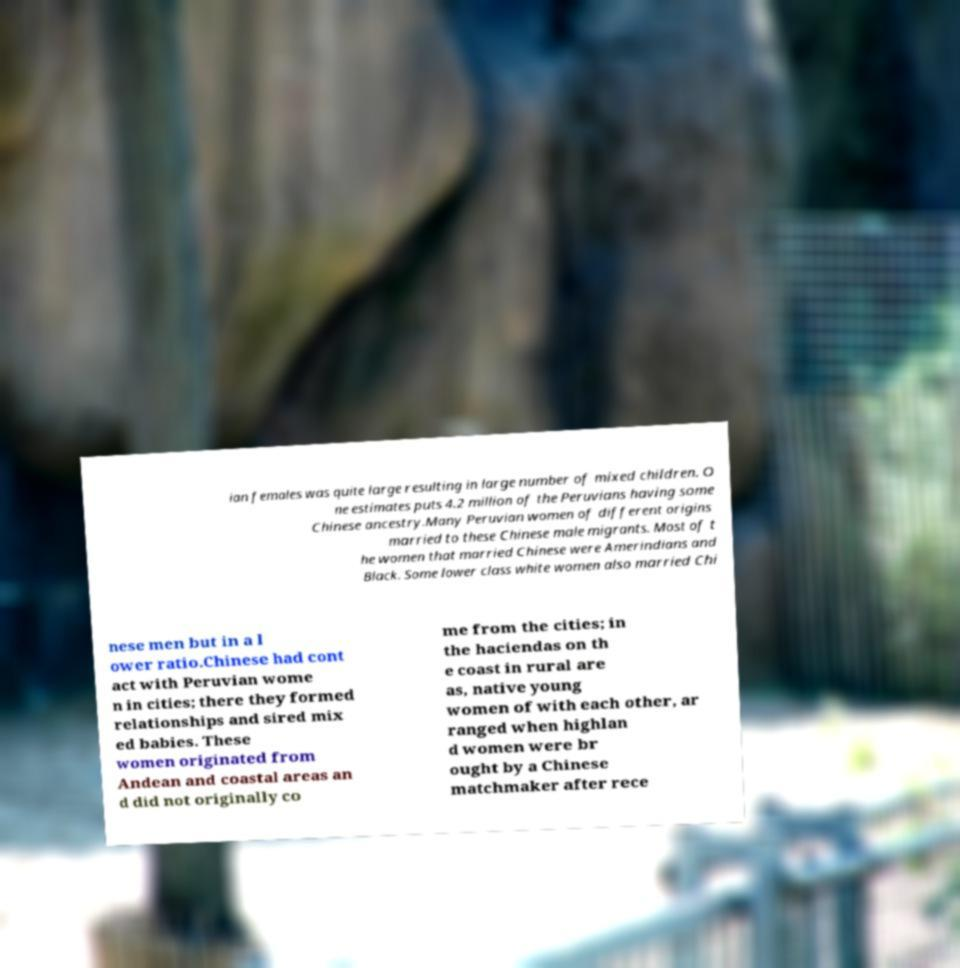I need the written content from this picture converted into text. Can you do that? ian females was quite large resulting in large number of mixed children. O ne estimates puts 4.2 million of the Peruvians having some Chinese ancestry.Many Peruvian women of different origins married to these Chinese male migrants. Most of t he women that married Chinese were Amerindians and Black. Some lower class white women also married Chi nese men but in a l ower ratio.Chinese had cont act with Peruvian wome n in cities; there they formed relationships and sired mix ed babies. These women originated from Andean and coastal areas an d did not originally co me from the cities; in the haciendas on th e coast in rural are as, native young women of with each other, ar ranged when highlan d women were br ought by a Chinese matchmaker after rece 